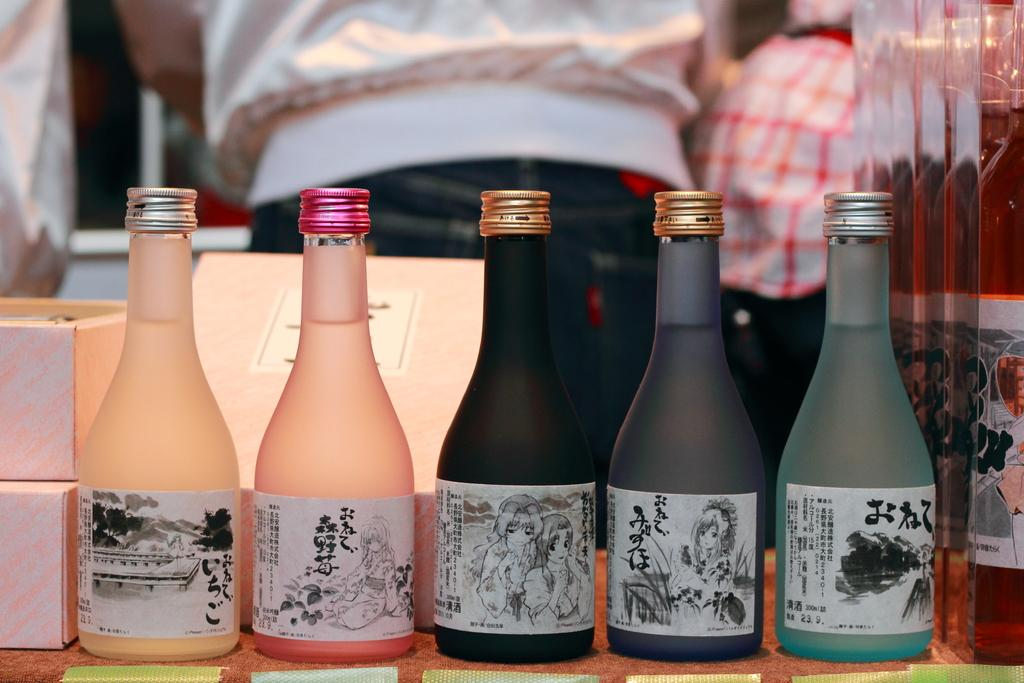How many bottles are visible in the image? There are five bottles in the image. What other objects can be seen in the image besides the bottles? There are boxes in the image. What type of hat is worn by the bottle on the left side of the image? There are no hats present in the image, as the main subjects are bottles and boxes. 